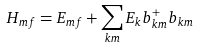Convert formula to latex. <formula><loc_0><loc_0><loc_500><loc_500>H _ { m f } = E _ { m f } + \sum _ { { k } m } E _ { k } b ^ { + } _ { { k } m } b _ { { k } m }</formula> 